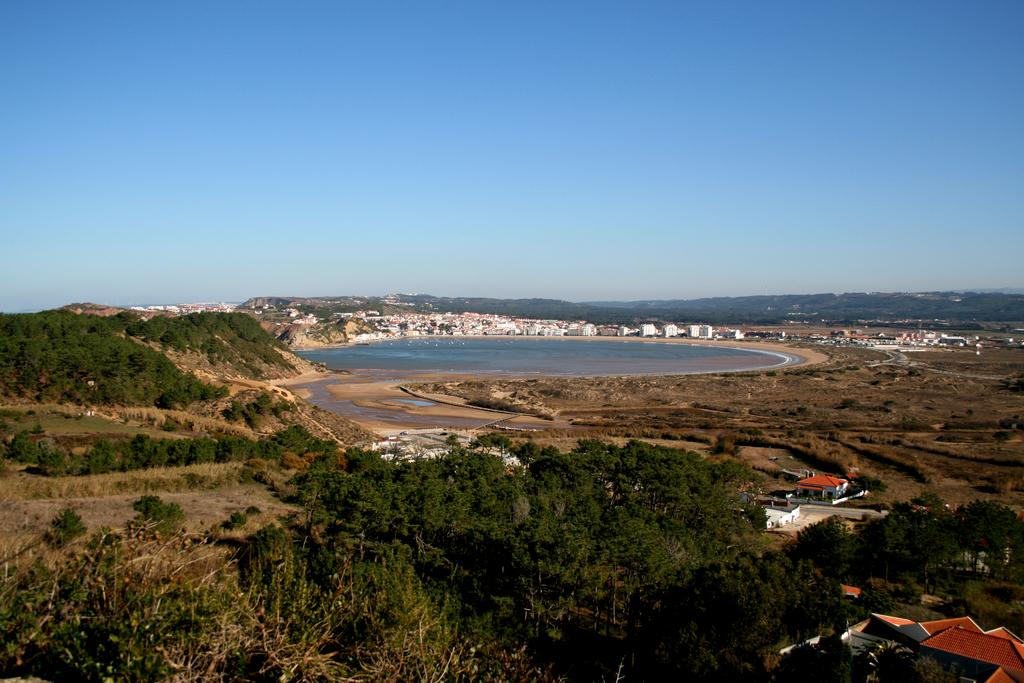What is the main feature in the center of the image? There is water in the center of the image. What else can be seen in the image besides the water? There are plants, buildings, and mountains in the image. What is visible at the top of the image? The sky is visible at the top of the image. How many tickets are needed for the voyage in the image? There is no voyage or tickets present in the image; it features water, plants, buildings, mountains, and the sky. 